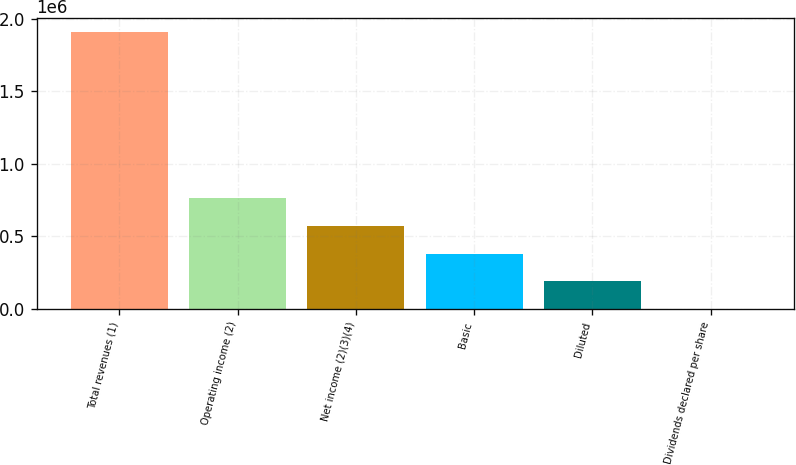<chart> <loc_0><loc_0><loc_500><loc_500><bar_chart><fcel>Total revenues (1)<fcel>Operating income (2)<fcel>Net income (2)(3)(4)<fcel>Basic<fcel>Diluted<fcel>Dividends declared per share<nl><fcel>1.9096e+06<fcel>763841<fcel>572881<fcel>381921<fcel>190961<fcel>0.48<nl></chart> 